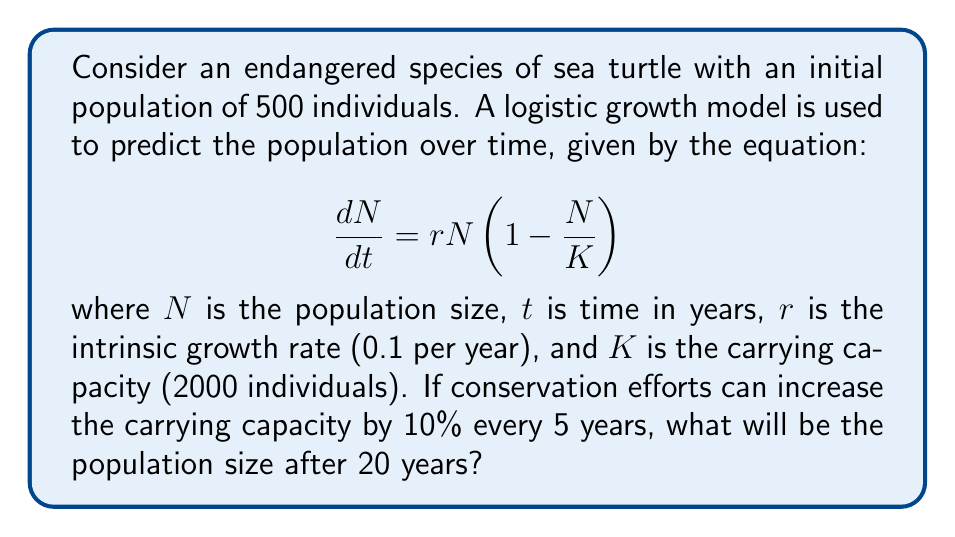Show me your answer to this math problem. To solve this problem, we need to follow these steps:

1. Determine the changing carrying capacity over time:
   - Initial K = 2000
   - After 5 years: K = 2000 * 1.1 = 2200
   - After 10 years: K = 2200 * 1.1 = 2420
   - After 15 years: K = 2420 * 1.1 = 2662
   - After 20 years: K = 2662 * 1.1 = 2928.2

2. Use the logistic growth model to calculate the population at each 5-year interval:

   The solution to the logistic growth equation is:

   $$N(t) = \frac{K}{1 + \left(\frac{K}{N_0} - 1\right)e^{-rt}}$$

   where $N_0$ is the initial population.

3. Calculate the population at t = 5, 10, 15, and 20 years:

   At t = 5:
   $$N(5) = \frac{2200}{1 + \left(\frac{2200}{500} - 1\right)e^{-0.1 \cdot 5}} \approx 731.7$$

   At t = 10:
   $$N(10) = \frac{2420}{1 + \left(\frac{2420}{731.7} - 1\right)e^{-0.1 \cdot 5}} \approx 1059.8$$

   At t = 15:
   $$N(15) = \frac{2662}{1 + \left(\frac{2662}{1059.8} - 1\right)e^{-0.1 \cdot 5}} \approx 1455.7$$

   At t = 20:
   $$N(20) = \frac{2928.2}{1 + \left(\frac{2928.2}{1455.7} - 1\right)e^{-0.1 \cdot 5}} \approx 1898.5$$

Therefore, after 20 years, the population size will be approximately 1899 sea turtles.
Answer: 1899 sea turtles 